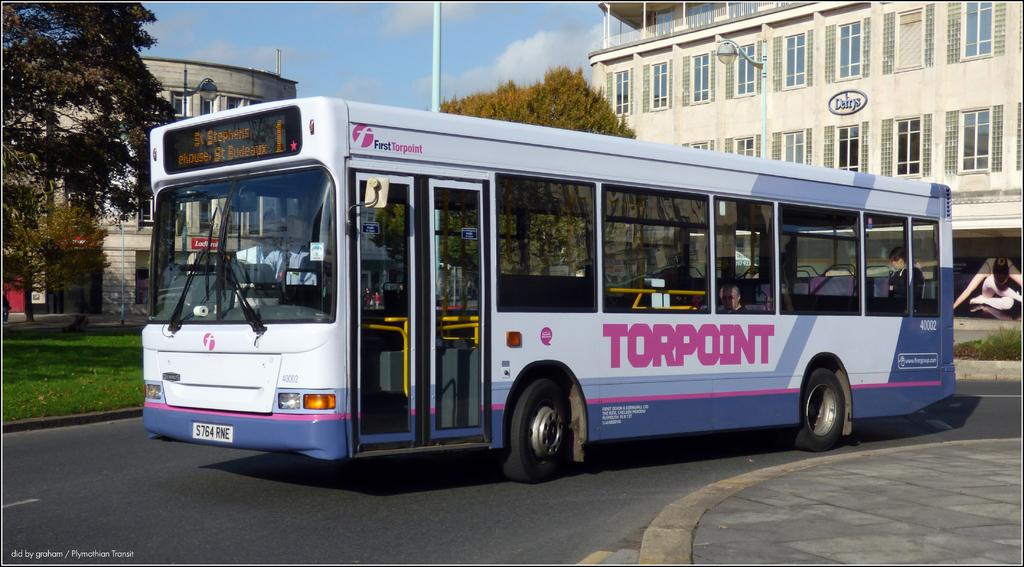<image>
Render a clear and concise summary of the photo. a single decker bus with the word Torpoint written on the side. 